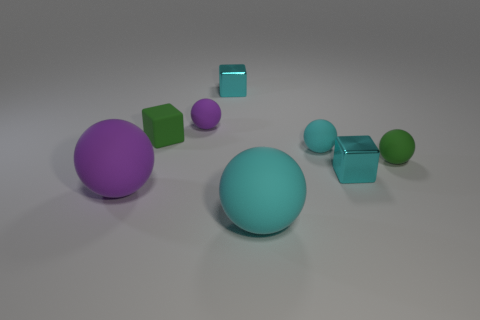There is a cyan block that is in front of the purple thing that is behind the small green rubber ball; what is its material?
Your answer should be very brief. Metal. There is a matte thing that is the same color as the matte block; what size is it?
Offer a very short reply. Small. Is there a matte thing that has the same color as the rubber cube?
Provide a short and direct response. Yes. Is the number of cyan rubber objects that are behind the big purple sphere greater than the number of tiny blue metallic spheres?
Provide a short and direct response. Yes. Is the shape of the tiny cyan rubber thing the same as the big rubber thing that is right of the large purple sphere?
Keep it short and to the point. Yes. Are there any tiny purple shiny cylinders?
Provide a short and direct response. No. How many small things are green things or cyan things?
Your answer should be compact. 5. Is the number of cyan matte balls that are in front of the tiny green sphere greater than the number of big cyan rubber things behind the small purple matte object?
Keep it short and to the point. Yes. Is the material of the green cube the same as the cyan cube behind the tiny purple object?
Provide a succinct answer. No. The tiny matte block has what color?
Provide a succinct answer. Green. 